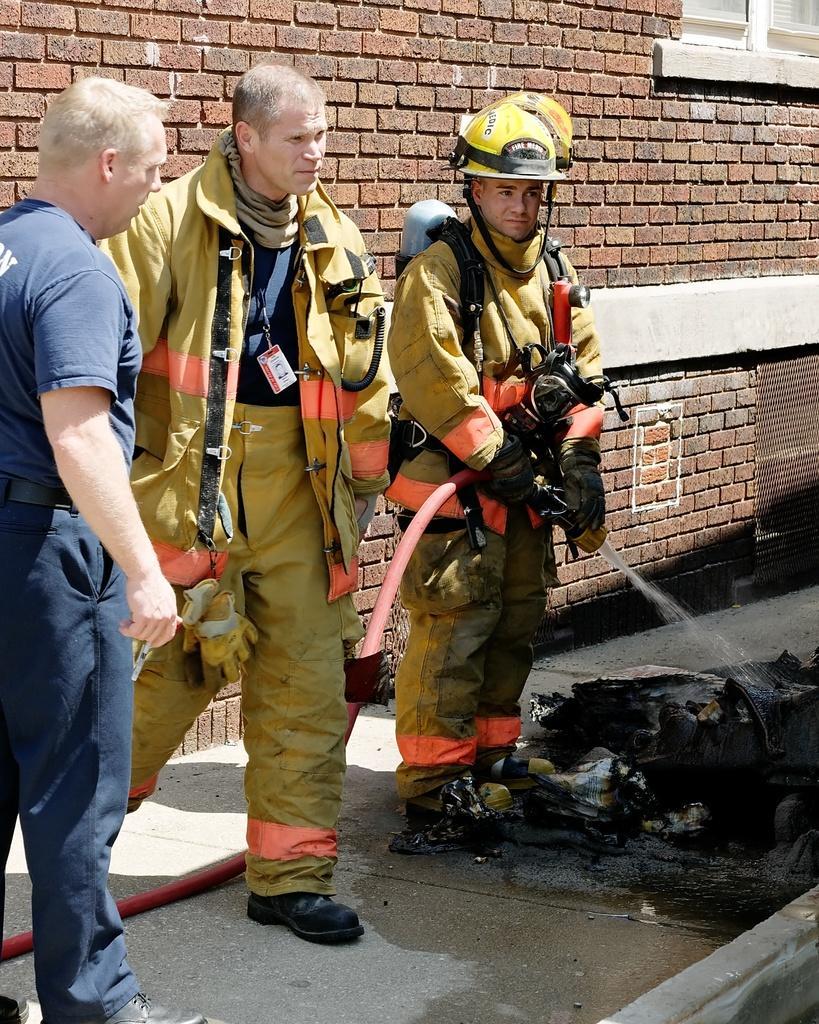In one or two sentences, can you explain what this image depicts? There are three persons standing and the person in the right is holding a pipe in his hand where water is coming from it and there is a building behind them which is in brick color. 